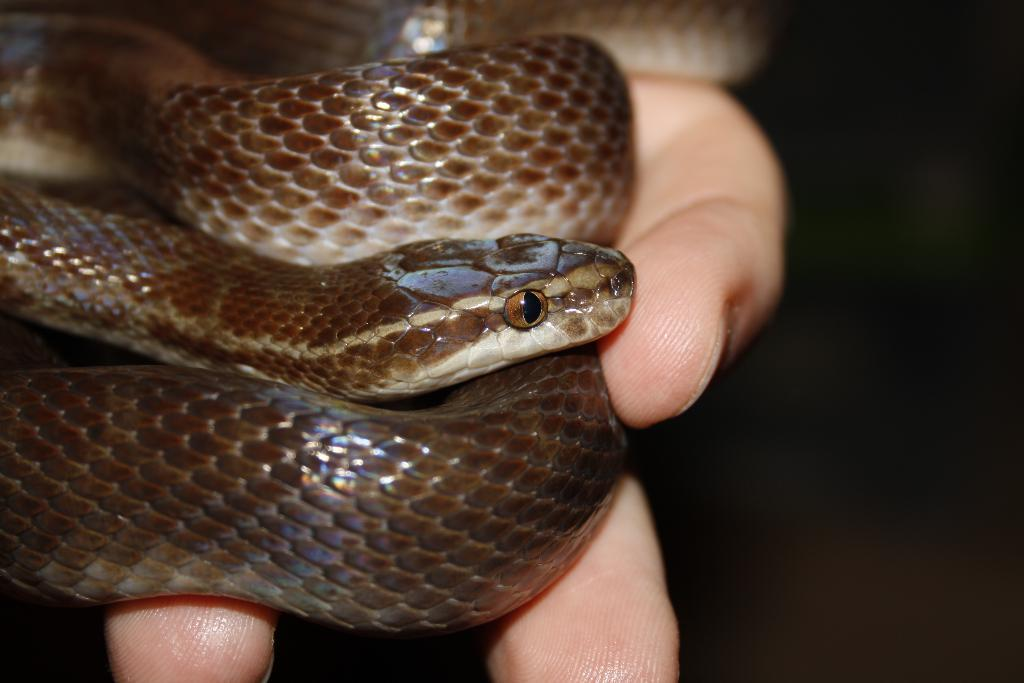What is visible in the image? There is a person's hand in the image. What is the hand holding? The hand is holding a snake. What type of insect can be seen crawling on the person's hand in the image? There is no insect visible in the image; the hand is holding a snake. What type of writing instrument is present in the image? There is no pen present in the image. What type of weightlifting equipment can be seen in the image? There is no weightlifting equipment present in the image. 